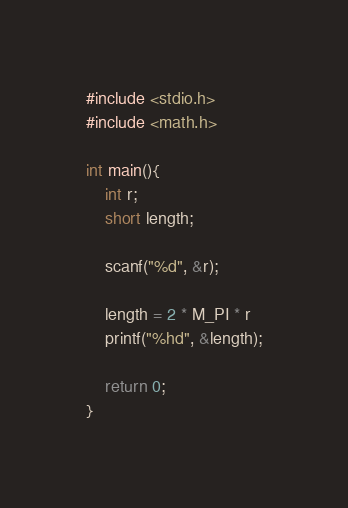<code> <loc_0><loc_0><loc_500><loc_500><_C_>#include <stdio.h>
#include <math.h>

int main(){
    int r;
    short length;

    scanf("%d", &r);
    
    length = 2 * M_PI * r
    printf("%hd", &length);

    return 0;
}</code> 